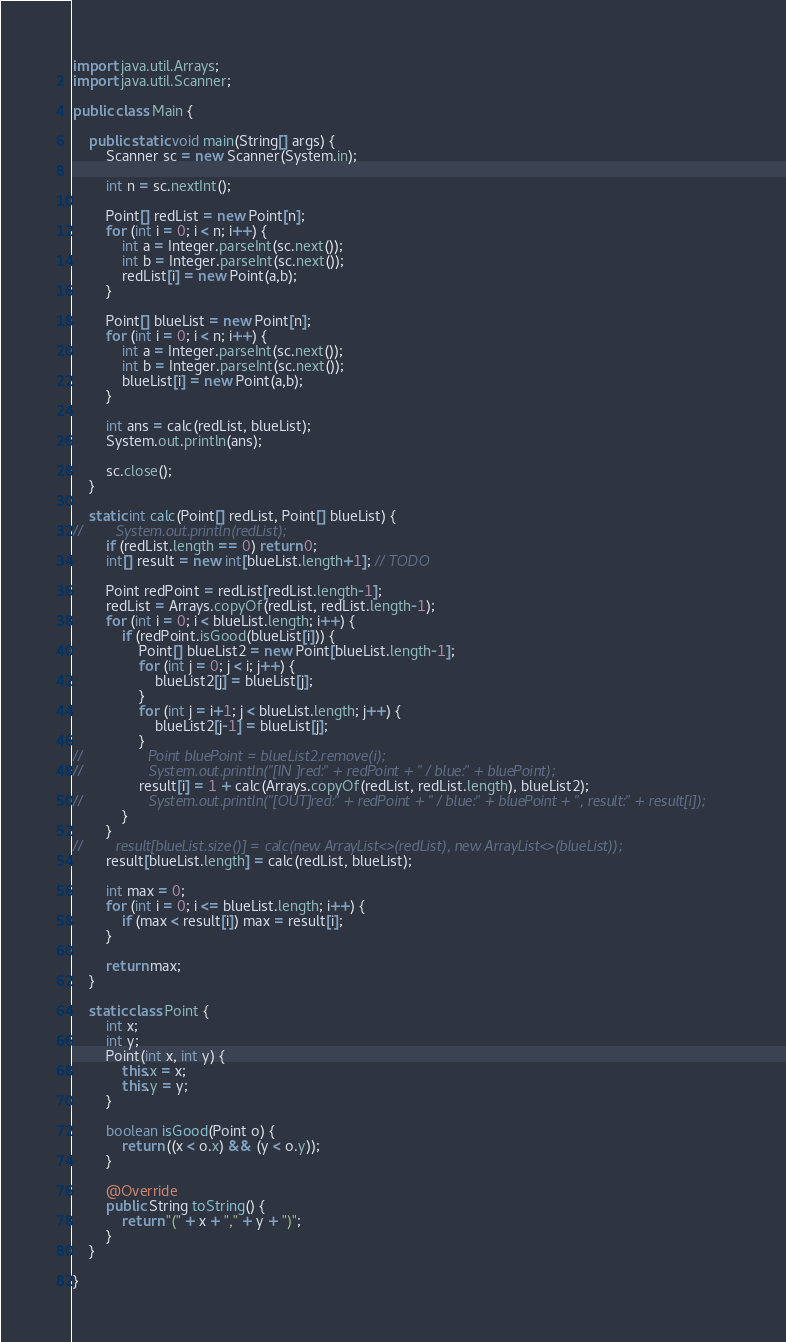Convert code to text. <code><loc_0><loc_0><loc_500><loc_500><_Java_>
import java.util.Arrays;
import java.util.Scanner;

public class Main {

    public static void main(String[] args) {
        Scanner sc = new Scanner(System.in);

        int n = sc.nextInt();

        Point[] redList = new Point[n];
        for (int i = 0; i < n; i++) {
            int a = Integer.parseInt(sc.next());
            int b = Integer.parseInt(sc.next());
            redList[i] = new Point(a,b);
        }

        Point[] blueList = new Point[n];
        for (int i = 0; i < n; i++) {
            int a = Integer.parseInt(sc.next());
            int b = Integer.parseInt(sc.next());
            blueList[i] = new Point(a,b);
        }

        int ans = calc(redList, blueList);
        System.out.println(ans);

        sc.close();
    }

    static int calc(Point[] redList, Point[] blueList) {
//        System.out.println(redList);
        if (redList.length == 0) return 0;
        int[] result = new int[blueList.length+1]; // TODO

        Point redPoint = redList[redList.length-1];
        redList = Arrays.copyOf(redList, redList.length-1);
        for (int i = 0; i < blueList.length; i++) {
            if (redPoint.isGood(blueList[i])) {
                Point[] blueList2 = new Point[blueList.length-1];
                for (int j = 0; j < i; j++) {
                    blueList2[j] = blueList[j];
                }
                for (int j = i+1; j < blueList.length; j++) {
                    blueList2[j-1] = blueList[j];
                }
//                Point bluePoint = blueList2.remove(i);
//                System.out.println("[IN ]red:" + redPoint + " / blue:" + bluePoint);
                result[i] = 1 + calc(Arrays.copyOf(redList, redList.length), blueList2);
//                System.out.println("[OUT]red:" + redPoint + " / blue:" + bluePoint + ", result:" + result[i]);
            }
        }
//        result[blueList.size()] = calc(new ArrayList<>(redList), new ArrayList<>(blueList));
        result[blueList.length] = calc(redList, blueList);

        int max = 0;
        for (int i = 0; i <= blueList.length; i++) {
            if (max < result[i]) max = result[i];
        }

        return max;
    }

    static class Point {
        int x;
        int y;
        Point(int x, int y) {
            this.x = x;
            this.y = y;
        }

        boolean isGood(Point o) {
            return ((x < o.x) && (y < o.y));
        }

        @Override
        public String toString() {
            return "(" + x + "," + y + ")";
        }
    }

}
</code> 